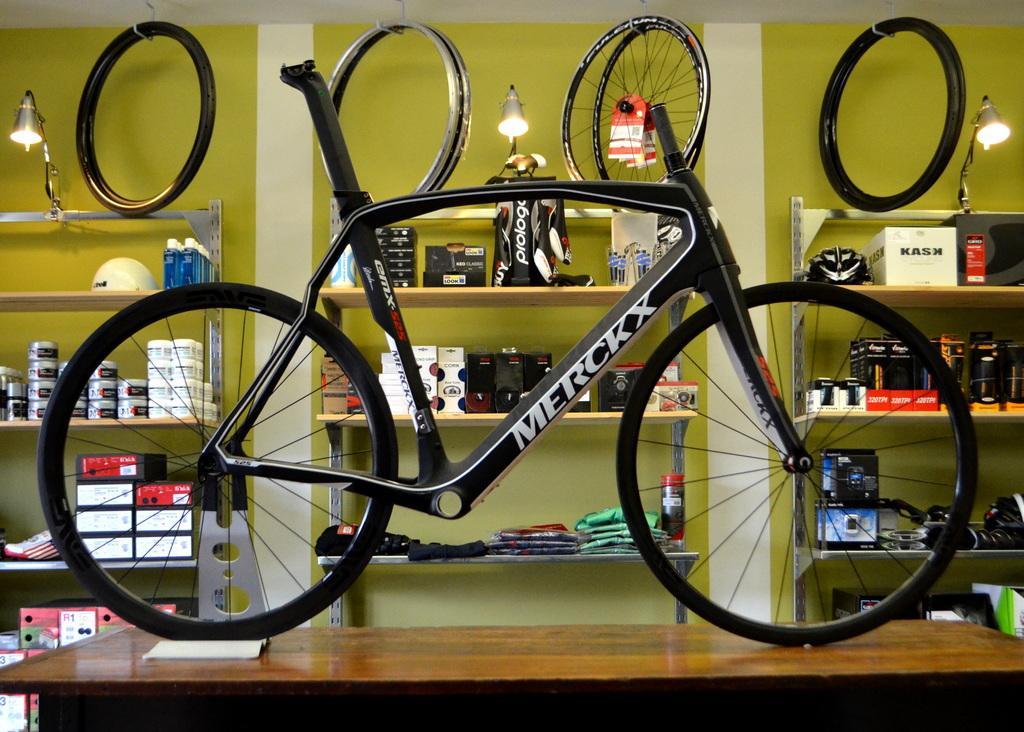Could you give a brief overview of what you see in this image? In this picture we can see a bicycle on the table and in the background we can see shelves,some objects. 